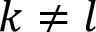<formula> <loc_0><loc_0><loc_500><loc_500>k \neq l</formula> 